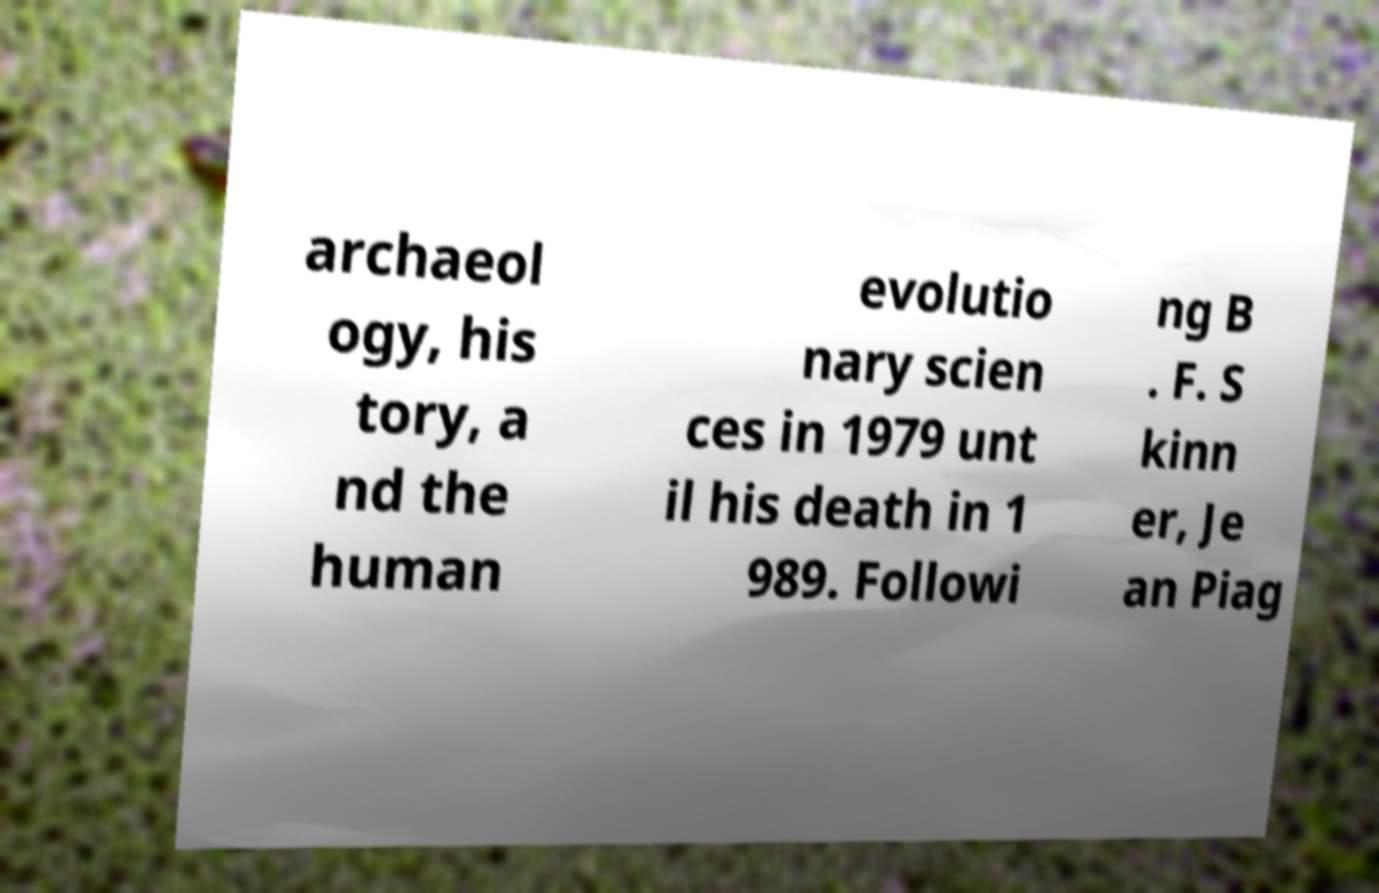I need the written content from this picture converted into text. Can you do that? archaeol ogy, his tory, a nd the human evolutio nary scien ces in 1979 unt il his death in 1 989. Followi ng B . F. S kinn er, Je an Piag 